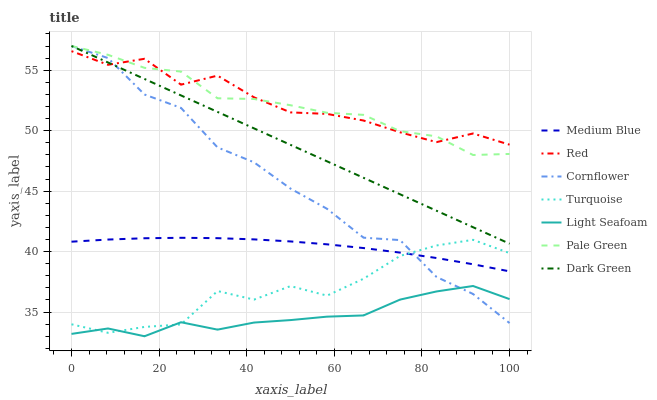Does Light Seafoam have the minimum area under the curve?
Answer yes or no. Yes. Does Red have the maximum area under the curve?
Answer yes or no. Yes. Does Turquoise have the minimum area under the curve?
Answer yes or no. No. Does Turquoise have the maximum area under the curve?
Answer yes or no. No. Is Dark Green the smoothest?
Answer yes or no. Yes. Is Cornflower the roughest?
Answer yes or no. Yes. Is Turquoise the smoothest?
Answer yes or no. No. Is Turquoise the roughest?
Answer yes or no. No. Does Light Seafoam have the lowest value?
Answer yes or no. Yes. Does Turquoise have the lowest value?
Answer yes or no. No. Does Dark Green have the highest value?
Answer yes or no. Yes. Does Turquoise have the highest value?
Answer yes or no. No. Is Medium Blue less than Red?
Answer yes or no. Yes. Is Dark Green greater than Medium Blue?
Answer yes or no. Yes. Does Pale Green intersect Red?
Answer yes or no. Yes. Is Pale Green less than Red?
Answer yes or no. No. Is Pale Green greater than Red?
Answer yes or no. No. Does Medium Blue intersect Red?
Answer yes or no. No. 